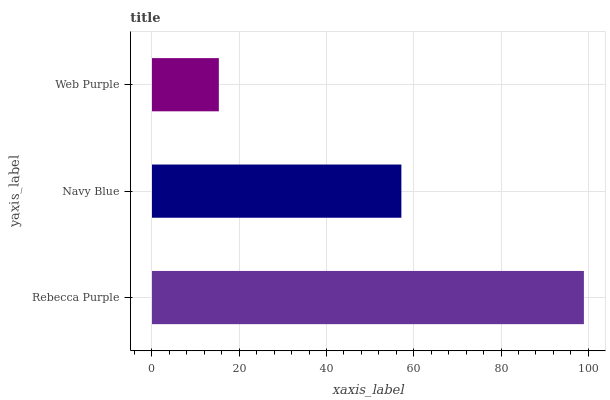Is Web Purple the minimum?
Answer yes or no. Yes. Is Rebecca Purple the maximum?
Answer yes or no. Yes. Is Navy Blue the minimum?
Answer yes or no. No. Is Navy Blue the maximum?
Answer yes or no. No. Is Rebecca Purple greater than Navy Blue?
Answer yes or no. Yes. Is Navy Blue less than Rebecca Purple?
Answer yes or no. Yes. Is Navy Blue greater than Rebecca Purple?
Answer yes or no. No. Is Rebecca Purple less than Navy Blue?
Answer yes or no. No. Is Navy Blue the high median?
Answer yes or no. Yes. Is Navy Blue the low median?
Answer yes or no. Yes. Is Web Purple the high median?
Answer yes or no. No. Is Rebecca Purple the low median?
Answer yes or no. No. 